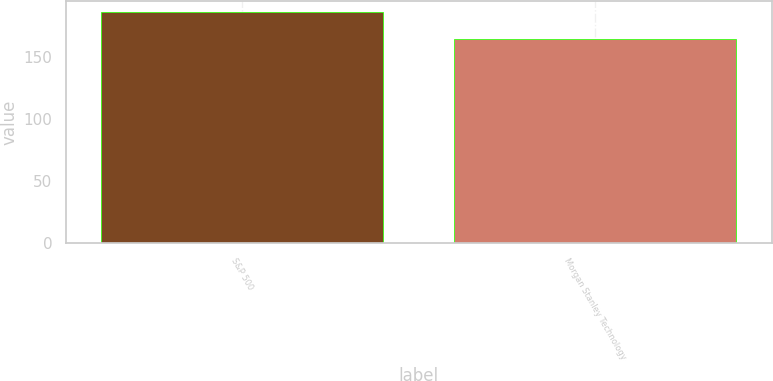<chart> <loc_0><loc_0><loc_500><loc_500><bar_chart><fcel>S&P 500<fcel>Morgan Stanley Technology<nl><fcel>185.8<fcel>164.45<nl></chart> 